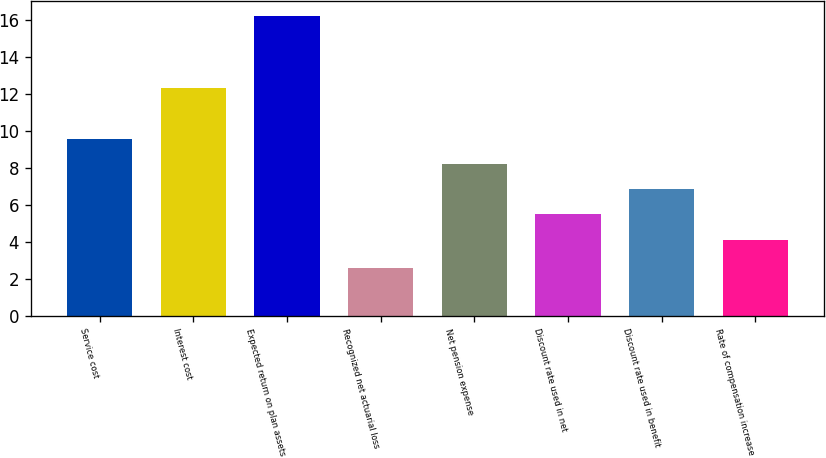Convert chart to OTSL. <chart><loc_0><loc_0><loc_500><loc_500><bar_chart><fcel>Service cost<fcel>Interest cost<fcel>Expected return on plan assets<fcel>Recognized net actuarial loss<fcel>Net pension expense<fcel>Discount rate used in net<fcel>Discount rate used in benefit<fcel>Rate of compensation increase<nl><fcel>9.58<fcel>12.3<fcel>16.2<fcel>2.6<fcel>8.22<fcel>5.5<fcel>6.86<fcel>4.1<nl></chart> 